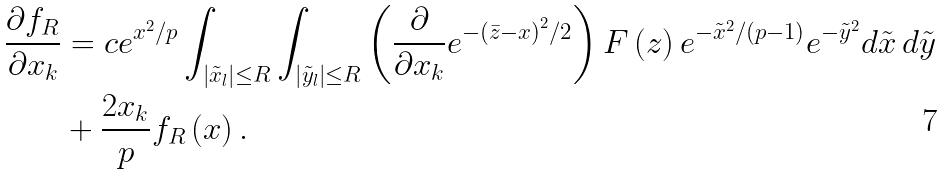<formula> <loc_0><loc_0><loc_500><loc_500>\frac { \partial f _ { R } } { \partial x _ { k } } & = c e ^ { x ^ { 2 } / p } \int _ { \left | \tilde { x } _ { l } \right | \leq R } \int _ { \left | \tilde { y } _ { l } \right | \leq R } \left ( \frac { \partial } { \partial x _ { k } } e ^ { - \left ( \bar { z } - x \right ) ^ { 2 } / 2 } \right ) F \left ( z \right ) e ^ { - \tilde { x } ^ { 2 } / ( p - 1 ) } e ^ { - \tilde { y } ^ { 2 } } d \tilde { x } \, d \tilde { y } \\ & + \frac { 2 x _ { k } } { p } f _ { R } \left ( x \right ) .</formula> 